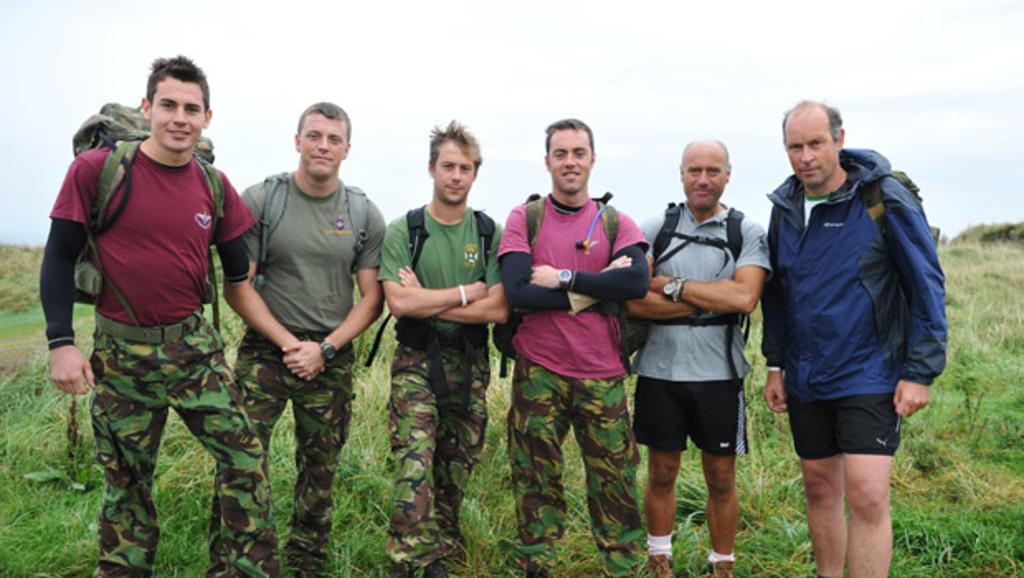Where was the image taken? The image was taken outside. What type of terrain is visible at the bottom of the image? There is grass at the bottom of the image. What are the persons in the image doing? The persons are standing in the middle of the image. What are the persons wearing on their backs? The persons are wearing backpacks. What is visible at the top of the image? The sky is visible at the top of the image. What type of bone can be seen sticking out of the person's leg in the image? There is no person with a bone sticking out of their leg in the image; the persons in the image are wearing backpacks and standing on grass. 